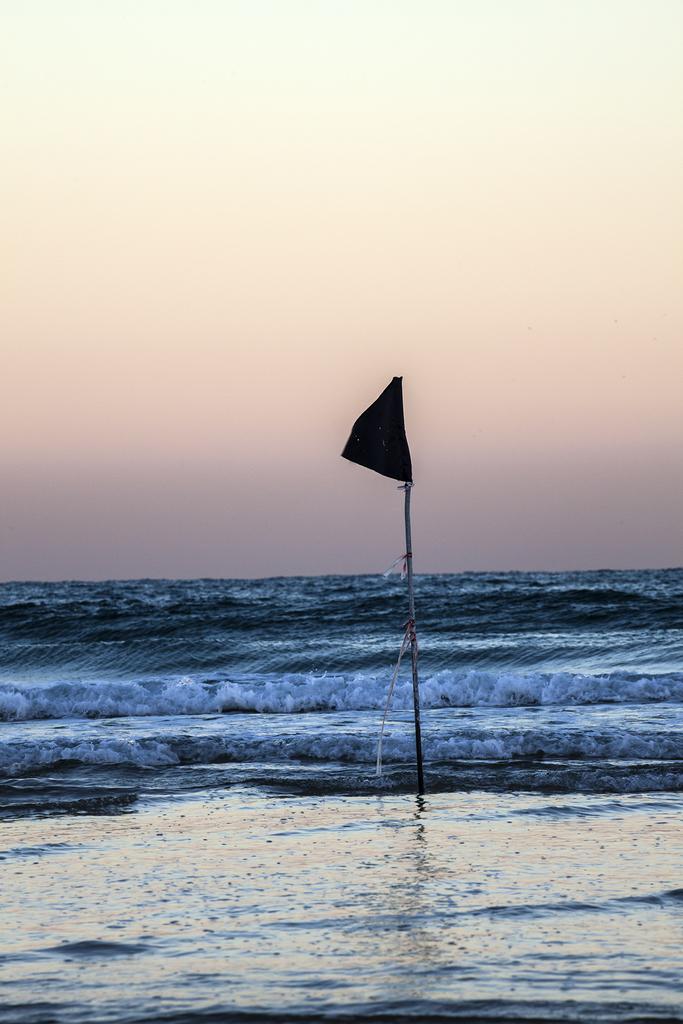Can you describe this image briefly? In this image we can see a flag in the water. In the background, we can see the sky. 